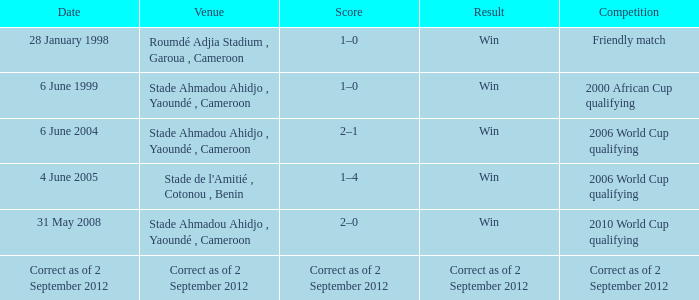What was the score in a friendly match? Win. 